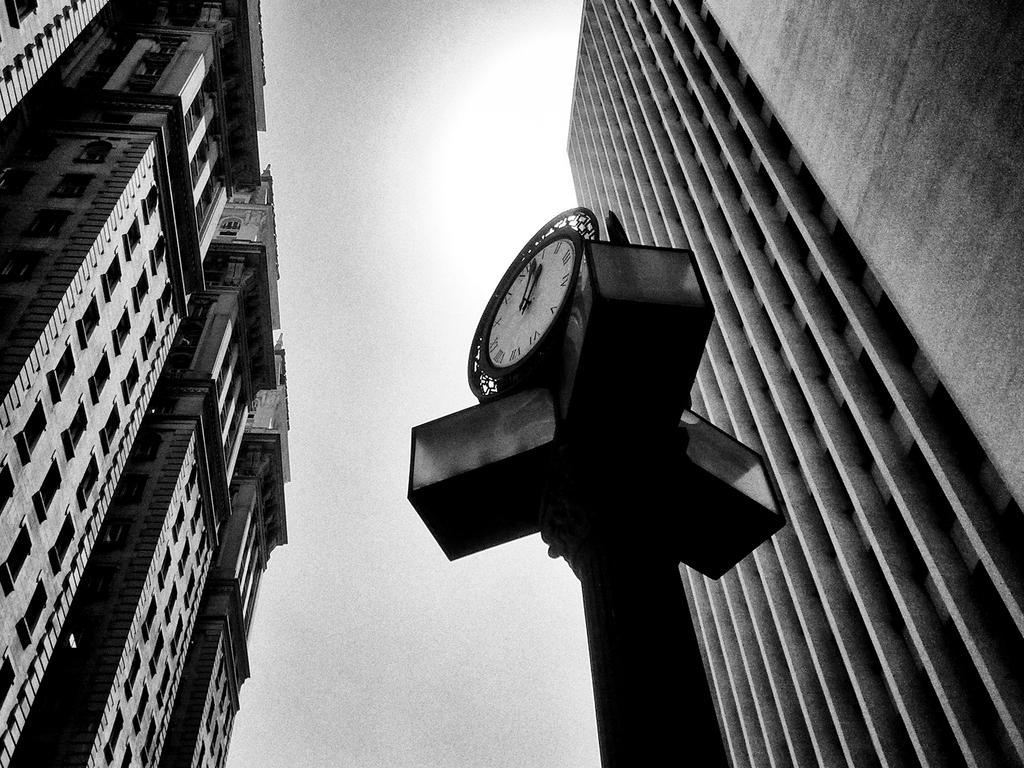How would you summarize this image in a sentence or two? In this black and white image there are buildings. In the center there is a pole. There is a clock to the pole. At the top there is the sky. 